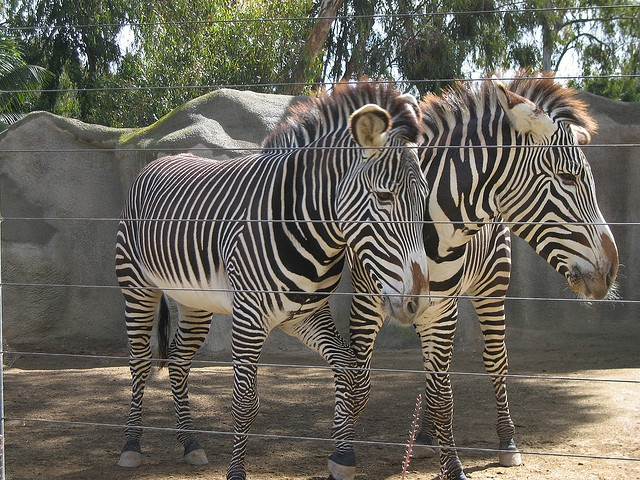Describe the objects in this image and their specific colors. I can see zebra in darkgray, black, and gray tones and zebra in darkgray, black, gray, and tan tones in this image. 